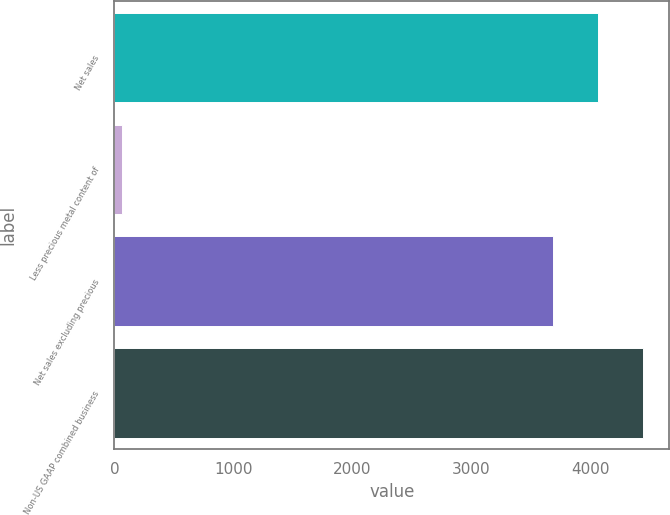<chart> <loc_0><loc_0><loc_500><loc_500><bar_chart><fcel>Net sales<fcel>Less precious metal content of<fcel>Net sales excluding precious<fcel>Non-US GAAP combined business<nl><fcel>4060.04<fcel>64.3<fcel>3681<fcel>4439.08<nl></chart> 